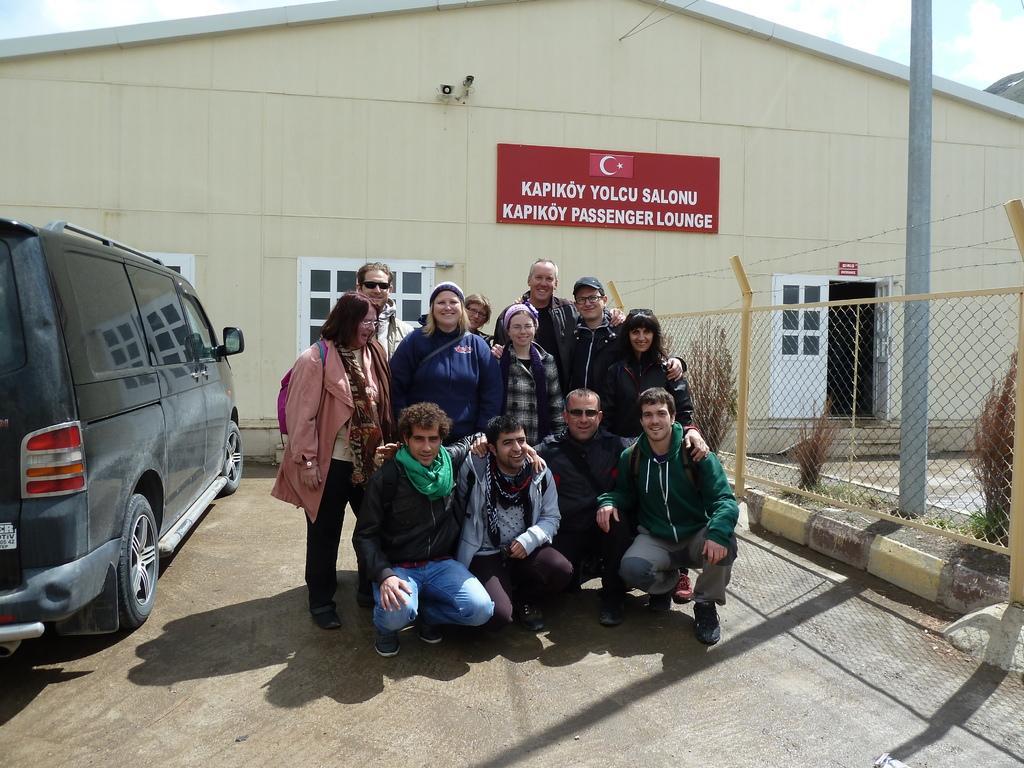Describe this image in one or two sentences. In this image, we can see people wearing clothes. There is a warehouse in the middle of the image. There is a vehicle on the left side of the image. There is a pole and fence on the right side of the image. There is a board at the top of the image. 